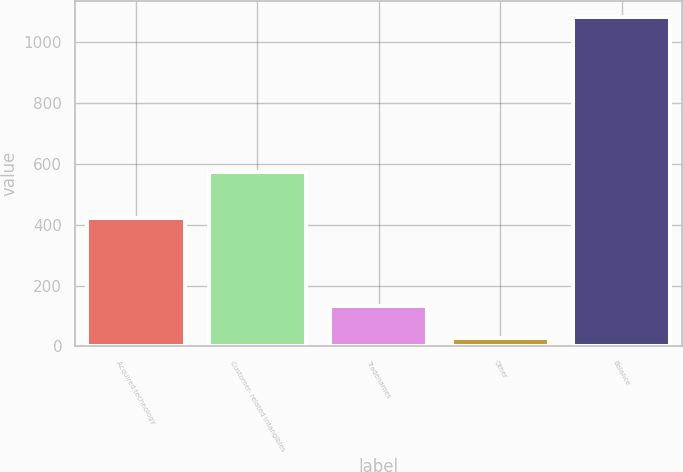Convert chart to OTSL. <chart><loc_0><loc_0><loc_500><loc_500><bar_chart><fcel>Acquired technology<fcel>Customer- related intangibles<fcel>Tradenames<fcel>Other<fcel>Balance<nl><fcel>421<fcel>574<fcel>131.6<fcel>26<fcel>1082<nl></chart> 